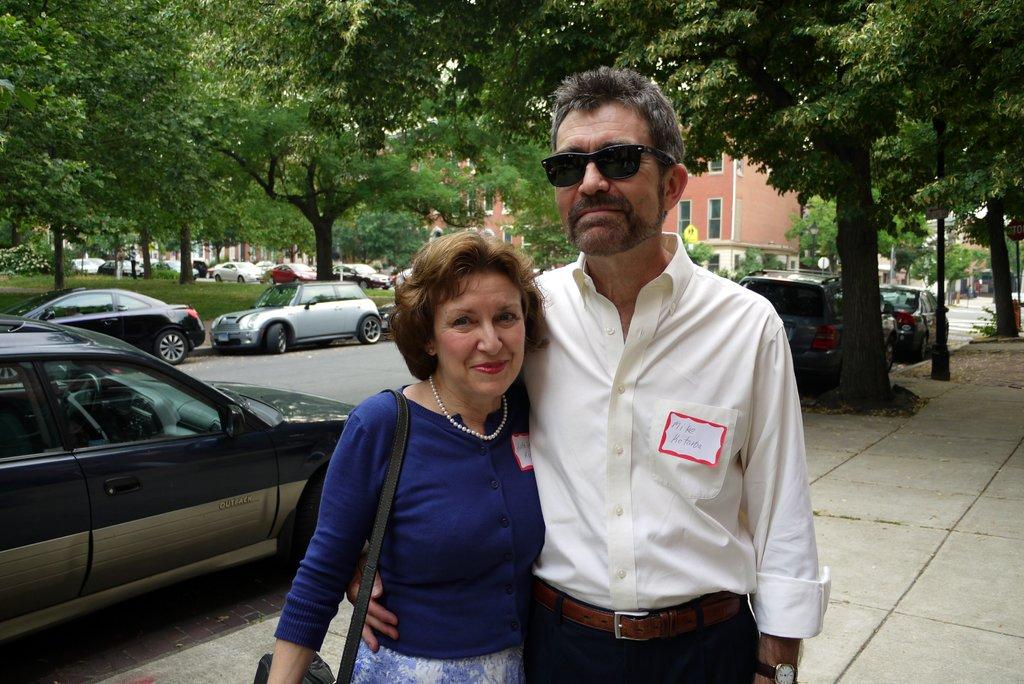How many people are in the image? There are two people in the image, a man and a woman. Where are the man and woman located in the image? They are on a footpath. What is beside the footpath in the image? There is a road beside the footpath. What is happening on the road in the image? Cars are parked on the road. What can be seen in the background of the image? There are trees in the background of the image. What type of beam is holding up the trees in the image? There is no beam present in the image; the trees are standing on their own. What color are the hands of the man and woman in the image? The image does not show the hands of the man and woman, so their colors cannot be determined. 